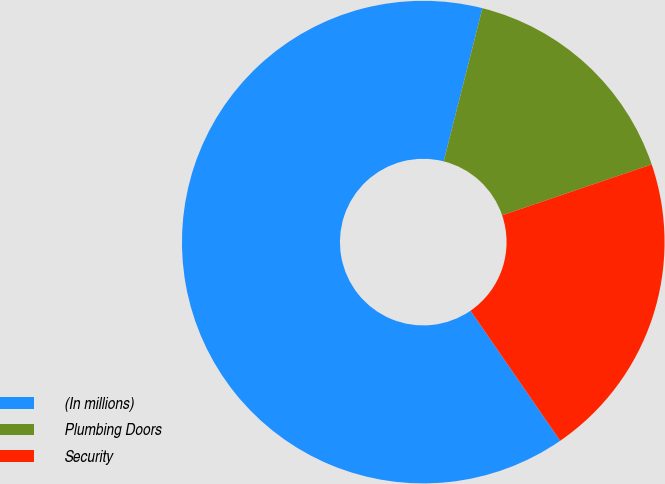Convert chart. <chart><loc_0><loc_0><loc_500><loc_500><pie_chart><fcel>(In millions)<fcel>Plumbing Doors<fcel>Security<nl><fcel>63.54%<fcel>15.84%<fcel>20.61%<nl></chart> 